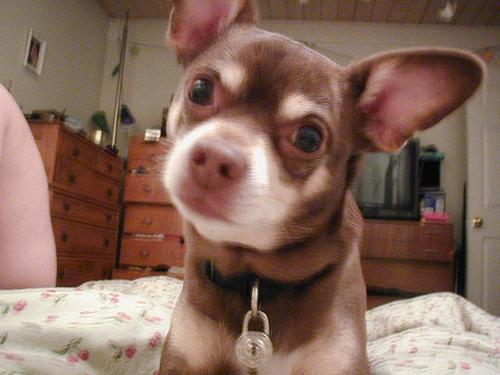How many different directions are the benches facing?
Give a very brief answer. 0. 